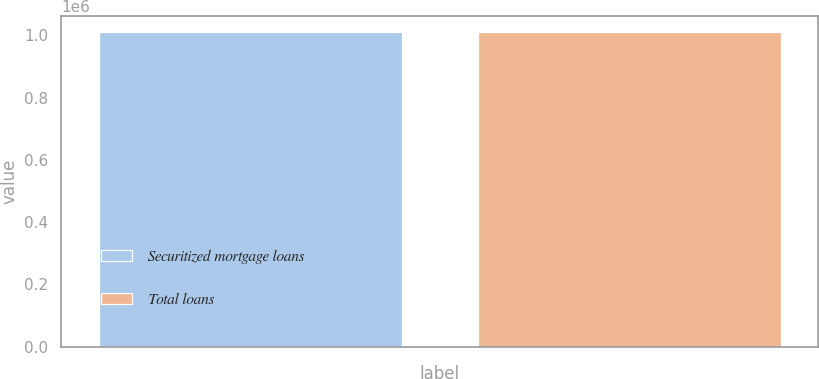Convert chart to OTSL. <chart><loc_0><loc_0><loc_500><loc_500><bar_chart><fcel>Securitized mortgage loans<fcel>Total loans<nl><fcel>1.01241e+06<fcel>1.01241e+06<nl></chart> 